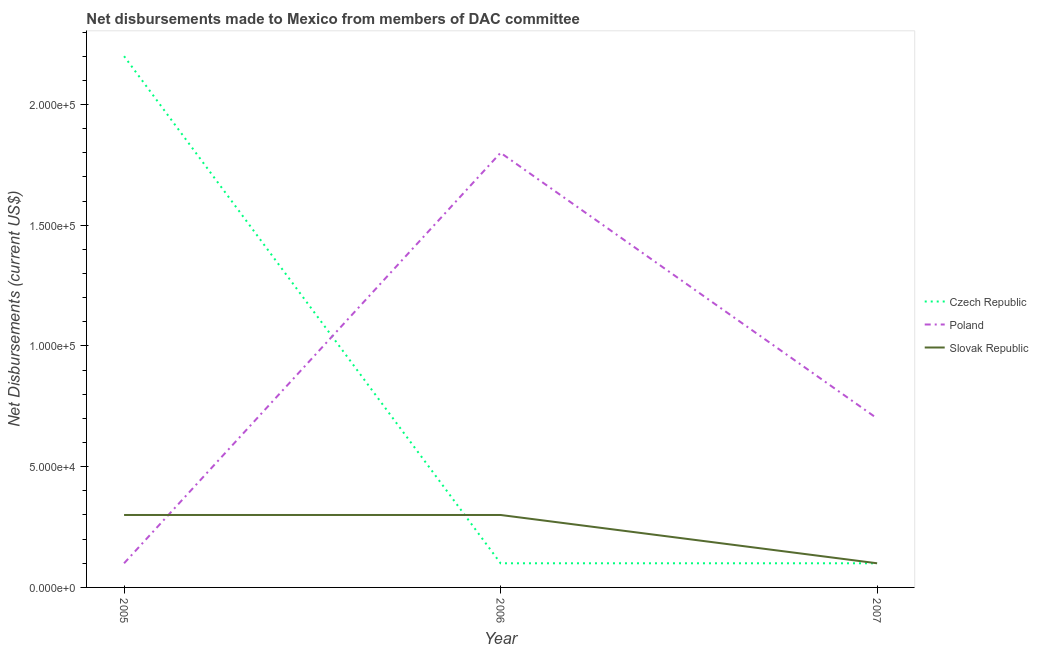Does the line corresponding to net disbursements made by poland intersect with the line corresponding to net disbursements made by czech republic?
Provide a short and direct response. Yes. What is the net disbursements made by czech republic in 2006?
Offer a terse response. 10000. Across all years, what is the maximum net disbursements made by slovak republic?
Keep it short and to the point. 3.00e+04. Across all years, what is the minimum net disbursements made by slovak republic?
Ensure brevity in your answer.  10000. In which year was the net disbursements made by poland maximum?
Provide a short and direct response. 2006. What is the total net disbursements made by poland in the graph?
Ensure brevity in your answer.  2.60e+05. What is the difference between the net disbursements made by czech republic in 2005 and that in 2006?
Provide a succinct answer. 2.10e+05. What is the difference between the net disbursements made by poland in 2007 and the net disbursements made by slovak republic in 2006?
Keep it short and to the point. 4.00e+04. What is the average net disbursements made by czech republic per year?
Give a very brief answer. 8.00e+04. In the year 2006, what is the difference between the net disbursements made by poland and net disbursements made by slovak republic?
Provide a short and direct response. 1.50e+05. Is the net disbursements made by poland in 2006 less than that in 2007?
Make the answer very short. No. Is the difference between the net disbursements made by poland in 2005 and 2007 greater than the difference between the net disbursements made by czech republic in 2005 and 2007?
Your answer should be very brief. No. What is the difference between the highest and the lowest net disbursements made by poland?
Provide a succinct answer. 1.70e+05. In how many years, is the net disbursements made by czech republic greater than the average net disbursements made by czech republic taken over all years?
Make the answer very short. 1. Is the sum of the net disbursements made by slovak republic in 2006 and 2007 greater than the maximum net disbursements made by czech republic across all years?
Ensure brevity in your answer.  No. Is it the case that in every year, the sum of the net disbursements made by czech republic and net disbursements made by poland is greater than the net disbursements made by slovak republic?
Make the answer very short. Yes. What is the difference between two consecutive major ticks on the Y-axis?
Offer a terse response. 5.00e+04. How are the legend labels stacked?
Make the answer very short. Vertical. What is the title of the graph?
Offer a terse response. Net disbursements made to Mexico from members of DAC committee. What is the label or title of the Y-axis?
Your answer should be very brief. Net Disbursements (current US$). What is the Net Disbursements (current US$) in Poland in 2005?
Your response must be concise. 10000. What is the Net Disbursements (current US$) of Slovak Republic in 2005?
Your answer should be compact. 3.00e+04. What is the Net Disbursements (current US$) in Czech Republic in 2006?
Offer a terse response. 10000. What is the Net Disbursements (current US$) of Czech Republic in 2007?
Ensure brevity in your answer.  10000. What is the Net Disbursements (current US$) of Poland in 2007?
Provide a short and direct response. 7.00e+04. Across all years, what is the minimum Net Disbursements (current US$) in Poland?
Give a very brief answer. 10000. What is the total Net Disbursements (current US$) of Czech Republic in the graph?
Make the answer very short. 2.40e+05. What is the total Net Disbursements (current US$) in Poland in the graph?
Your response must be concise. 2.60e+05. What is the total Net Disbursements (current US$) of Slovak Republic in the graph?
Provide a short and direct response. 7.00e+04. What is the difference between the Net Disbursements (current US$) in Czech Republic in 2005 and that in 2006?
Provide a succinct answer. 2.10e+05. What is the difference between the Net Disbursements (current US$) of Poland in 2005 and that in 2006?
Ensure brevity in your answer.  -1.70e+05. What is the difference between the Net Disbursements (current US$) in Poland in 2005 and that in 2007?
Your answer should be very brief. -6.00e+04. What is the difference between the Net Disbursements (current US$) in Slovak Republic in 2005 and that in 2007?
Your answer should be compact. 2.00e+04. What is the difference between the Net Disbursements (current US$) of Poland in 2006 and that in 2007?
Keep it short and to the point. 1.10e+05. What is the difference between the Net Disbursements (current US$) in Slovak Republic in 2006 and that in 2007?
Your answer should be very brief. 2.00e+04. What is the difference between the Net Disbursements (current US$) of Czech Republic in 2005 and the Net Disbursements (current US$) of Poland in 2006?
Provide a short and direct response. 4.00e+04. What is the difference between the Net Disbursements (current US$) of Czech Republic in 2005 and the Net Disbursements (current US$) of Slovak Republic in 2007?
Ensure brevity in your answer.  2.10e+05. What is the difference between the Net Disbursements (current US$) in Czech Republic in 2006 and the Net Disbursements (current US$) in Poland in 2007?
Your answer should be very brief. -6.00e+04. What is the average Net Disbursements (current US$) of Poland per year?
Your response must be concise. 8.67e+04. What is the average Net Disbursements (current US$) of Slovak Republic per year?
Your answer should be very brief. 2.33e+04. In the year 2005, what is the difference between the Net Disbursements (current US$) in Czech Republic and Net Disbursements (current US$) in Slovak Republic?
Your answer should be compact. 1.90e+05. In the year 2005, what is the difference between the Net Disbursements (current US$) in Poland and Net Disbursements (current US$) in Slovak Republic?
Make the answer very short. -2.00e+04. In the year 2007, what is the difference between the Net Disbursements (current US$) in Poland and Net Disbursements (current US$) in Slovak Republic?
Your answer should be compact. 6.00e+04. What is the ratio of the Net Disbursements (current US$) in Czech Republic in 2005 to that in 2006?
Keep it short and to the point. 22. What is the ratio of the Net Disbursements (current US$) in Poland in 2005 to that in 2006?
Keep it short and to the point. 0.06. What is the ratio of the Net Disbursements (current US$) in Poland in 2005 to that in 2007?
Your response must be concise. 0.14. What is the ratio of the Net Disbursements (current US$) in Slovak Republic in 2005 to that in 2007?
Make the answer very short. 3. What is the ratio of the Net Disbursements (current US$) in Czech Republic in 2006 to that in 2007?
Your response must be concise. 1. What is the ratio of the Net Disbursements (current US$) of Poland in 2006 to that in 2007?
Keep it short and to the point. 2.57. What is the difference between the highest and the second highest Net Disbursements (current US$) in Czech Republic?
Offer a very short reply. 2.10e+05. What is the difference between the highest and the second highest Net Disbursements (current US$) in Poland?
Give a very brief answer. 1.10e+05. What is the difference between the highest and the lowest Net Disbursements (current US$) in Czech Republic?
Provide a succinct answer. 2.10e+05. 